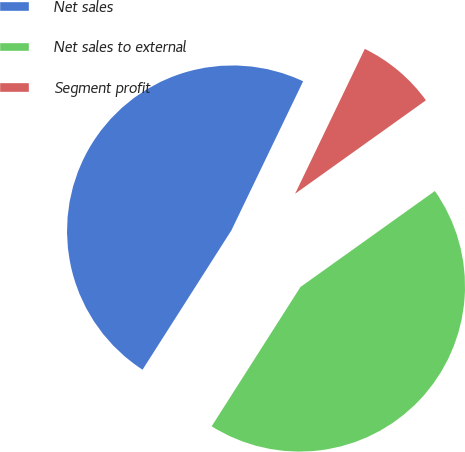Convert chart. <chart><loc_0><loc_0><loc_500><loc_500><pie_chart><fcel>Net sales<fcel>Net sales to external<fcel>Segment profit<nl><fcel>48.1%<fcel>43.9%<fcel>7.99%<nl></chart> 